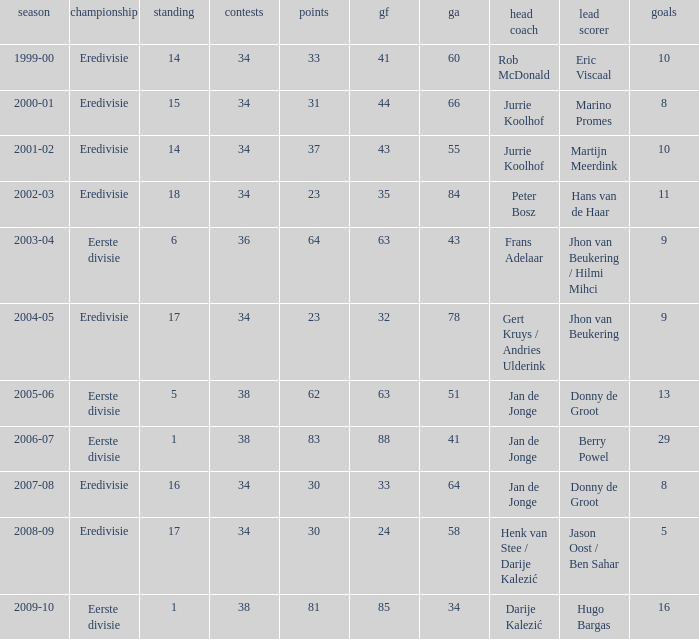What is the rank of manager Rob Mcdonald? 1.0. 